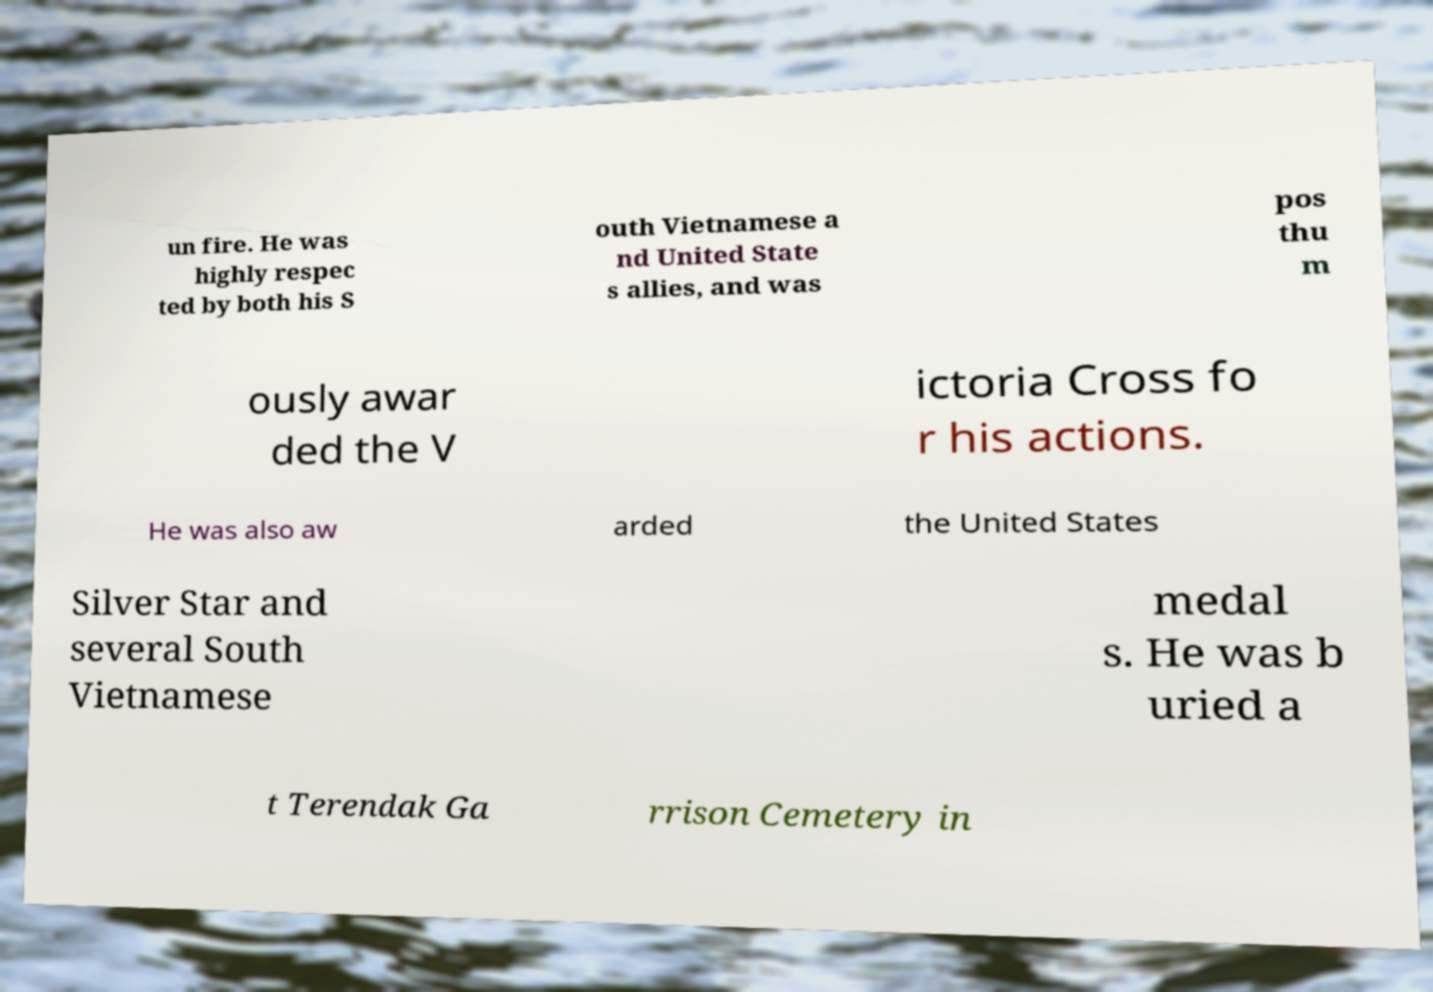Please read and relay the text visible in this image. What does it say? un fire. He was highly respec ted by both his S outh Vietnamese a nd United State s allies, and was pos thu m ously awar ded the V ictoria Cross fo r his actions. He was also aw arded the United States Silver Star and several South Vietnamese medal s. He was b uried a t Terendak Ga rrison Cemetery in 